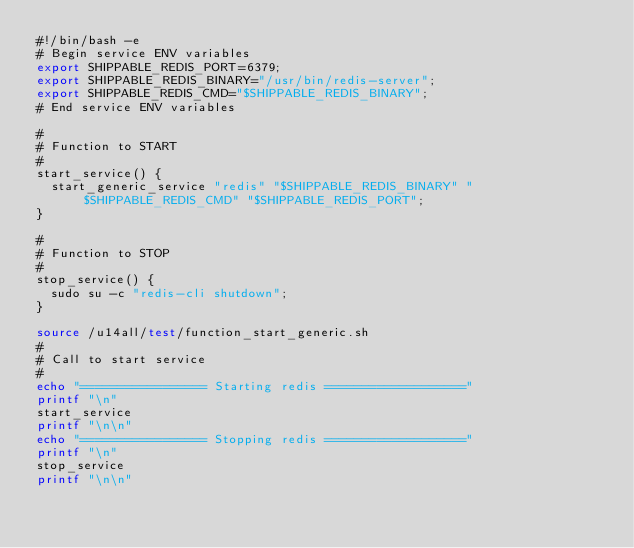Convert code to text. <code><loc_0><loc_0><loc_500><loc_500><_Bash_>#!/bin/bash -e
# Begin service ENV variables
export SHIPPABLE_REDIS_PORT=6379;
export SHIPPABLE_REDIS_BINARY="/usr/bin/redis-server";
export SHIPPABLE_REDIS_CMD="$SHIPPABLE_REDIS_BINARY";
# End service ENV variables

#
# Function to START
#
start_service() {
  start_generic_service "redis" "$SHIPPABLE_REDIS_BINARY" "$SHIPPABLE_REDIS_CMD" "$SHIPPABLE_REDIS_PORT";
}

#
# Function to STOP
#
stop_service() {
  sudo su -c "redis-cli shutdown";
}

source /u14all/test/function_start_generic.sh
#
# Call to start service
#
echo "================= Starting redis ==================="
printf "\n"
start_service
printf "\n\n"
echo "================= Stopping redis ==================="
printf "\n"
stop_service
printf "\n\n"
</code> 